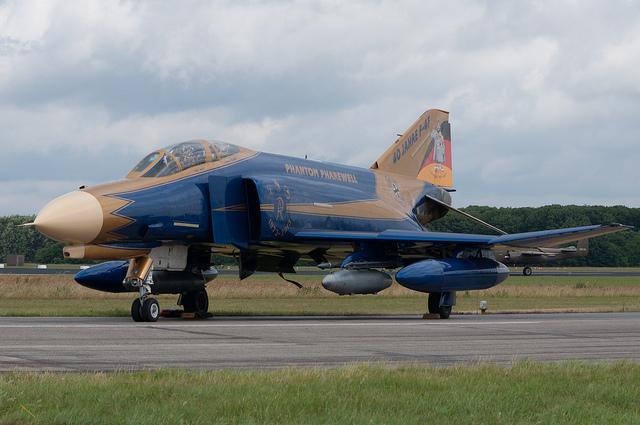Is the plane taxiing down the runway or are there chucks wedged under the wheels?
Concise answer only. Chucks wedged. Is this a rocket?
Be succinct. No. Is this plane in the air?
Give a very brief answer. No. 